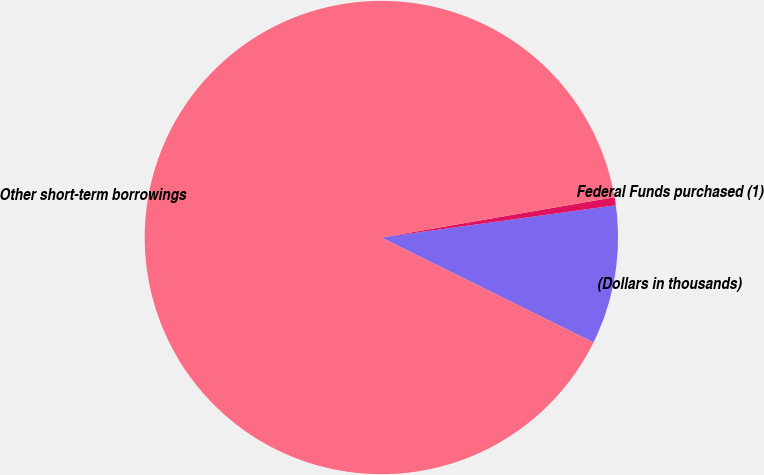Convert chart to OTSL. <chart><loc_0><loc_0><loc_500><loc_500><pie_chart><fcel>(Dollars in thousands)<fcel>Federal Funds purchased (1)<fcel>Other short-term borrowings<nl><fcel>9.49%<fcel>0.55%<fcel>89.97%<nl></chart> 